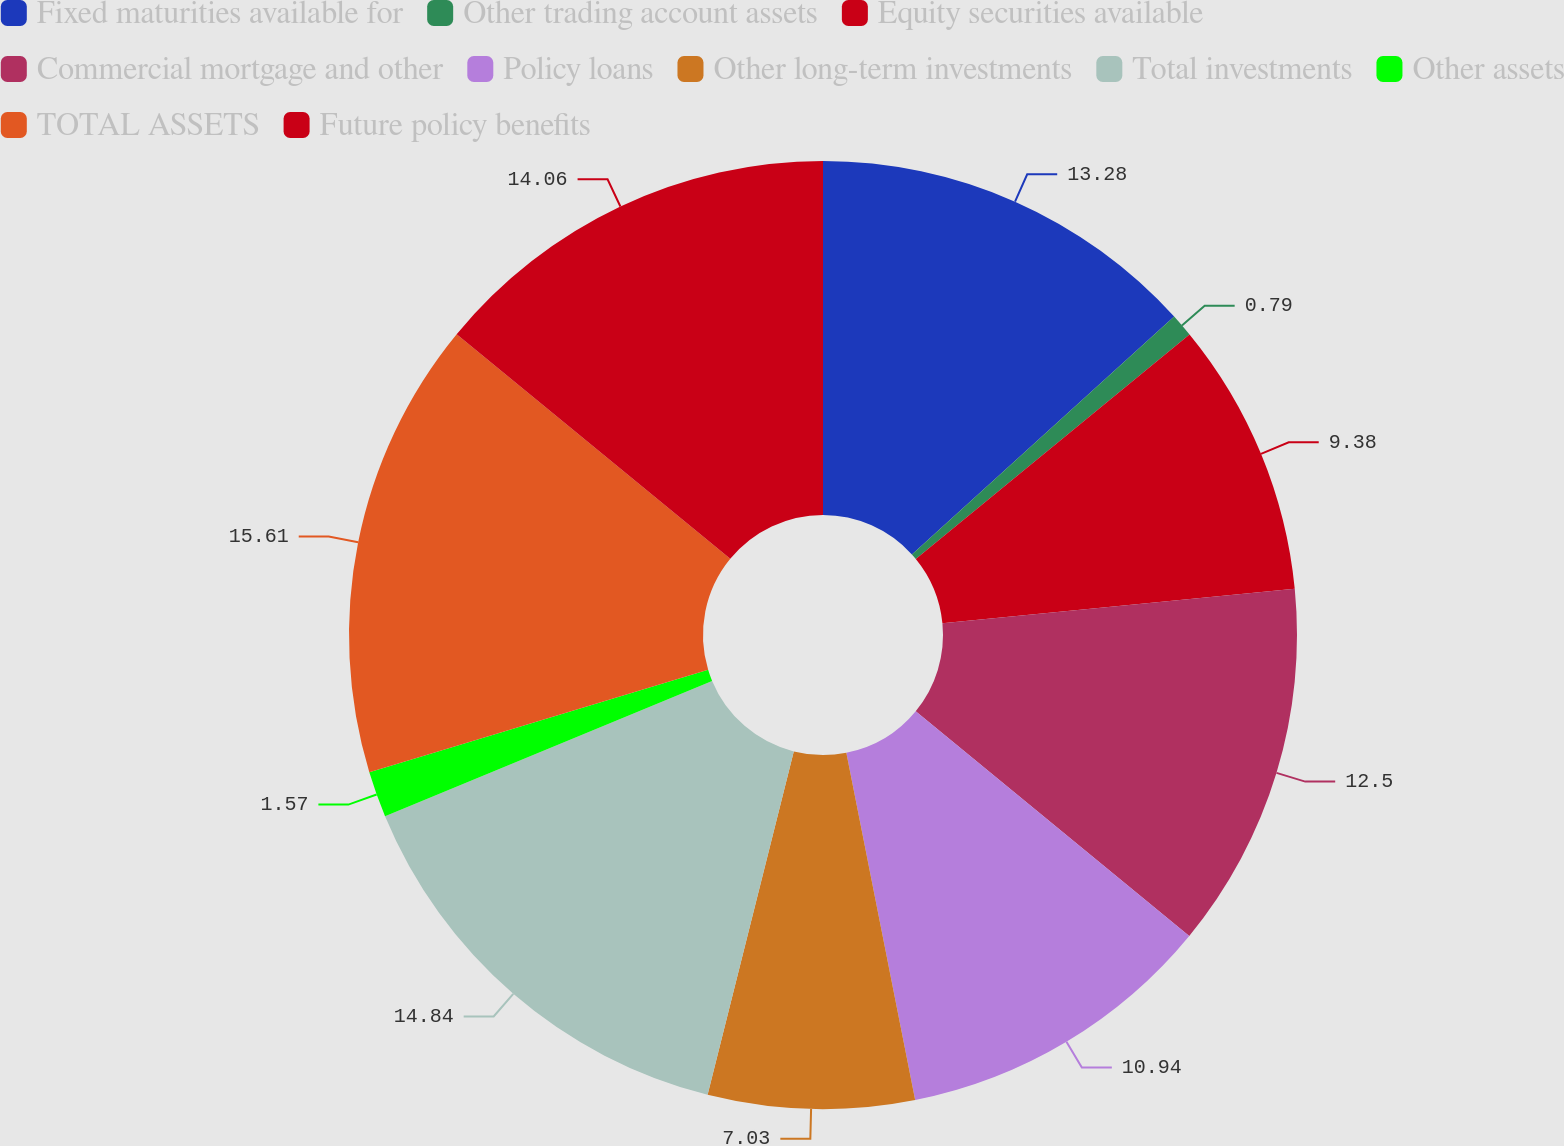Convert chart to OTSL. <chart><loc_0><loc_0><loc_500><loc_500><pie_chart><fcel>Fixed maturities available for<fcel>Other trading account assets<fcel>Equity securities available<fcel>Commercial mortgage and other<fcel>Policy loans<fcel>Other long-term investments<fcel>Total investments<fcel>Other assets<fcel>TOTAL ASSETS<fcel>Future policy benefits<nl><fcel>13.28%<fcel>0.79%<fcel>9.38%<fcel>12.5%<fcel>10.94%<fcel>7.03%<fcel>14.84%<fcel>1.57%<fcel>15.62%<fcel>14.06%<nl></chart> 